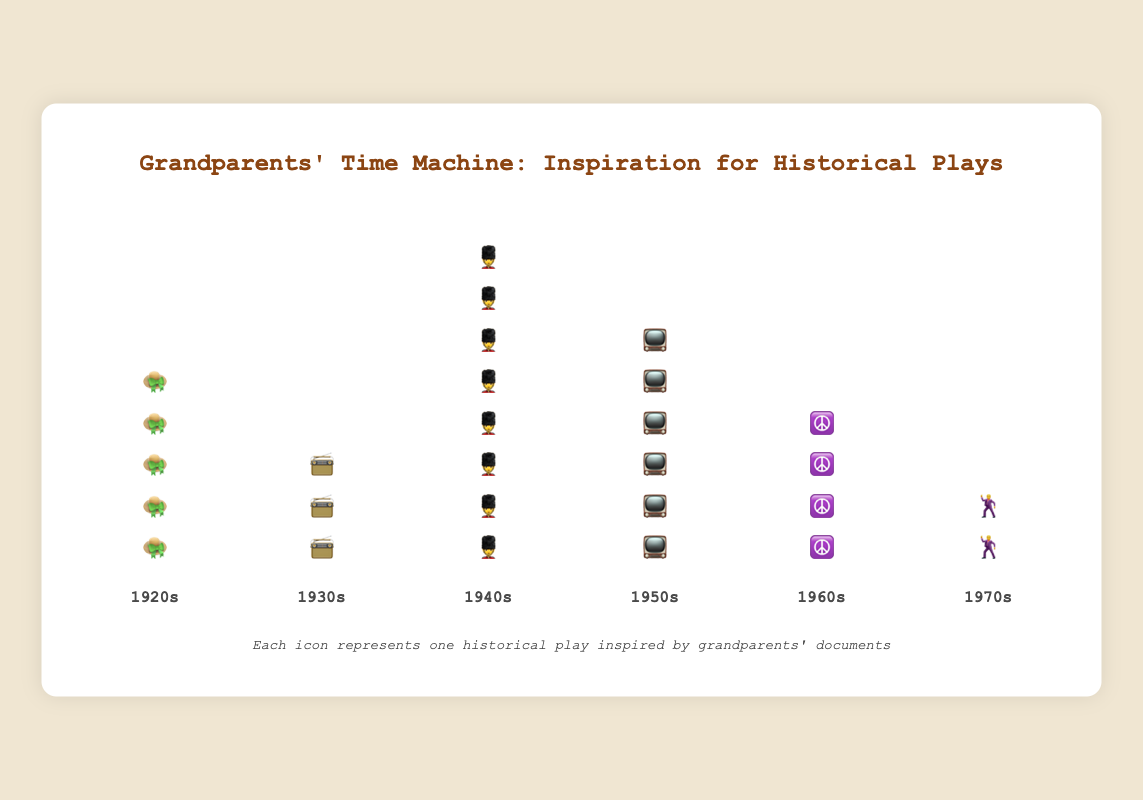what's the title of the figure? The title is positioned at the top of the figure and is clearly visible in a larger font. By reading this text, we can identify the main subject of the figure.
Answer: Grandparents' Time Machine: Inspiration for Historical Plays Which time period has the most historical plays represented? By counting the number of icons under each time period, we can see that the period with the most icons has the most plays. The 1940s has 8 soldier icons, the highest count.
Answer: 1940s How many total historical plays are represented in the figure? To find the total number of plays, we sum the counts of plays from each time period: 5 (1920s) + 3 (1930s) + 8 (1940s) + 6 (1950s) + 4 (1960s) + 2 (1970s).
Answer: 28 Which time periods have less than 5 historical plays represented? By examining each column and counting the icons, we identify periods with less than 5 icons, which are the 1930s and the 1970s.
Answer: 1930s, 1970s If you were to use icons to depict 2 more historical plays from the 1970s, how would that compare to the 1960s in terms of counts? By adding 2 to the current count of 2 plays from the 1970s, we get 4. Comparing this with the count for the 1960s, which also has 4, they will have equal amounts.
Answer: They would be equal What's the difference in the number of historical plays between the 1950s and the 1970s? By subtracting the count of plays in the 1970s (2) from the count in the 1950s (6), we get the difference, which is 4.
Answer: 4 Which time period immediately follows the 1940s in the timeline? By looking at the sequence of time periods from left to right, the period that comes directly after the 1940s is the 1950s.
Answer: 1950s Which icon represents the 1960s, and how many times is it used? By identifying the icon labeled under the 1960s and counting how many times it appears, we see the hippie ☮️ icon is used 4 times.
Answer: ☮️, 4 What is the average number of historical plays per time period? To find the average, sum the total number of plays (28) and divide by the number of periods (6): 28 / 6 = approximately 4.67
Answer: 4.67 